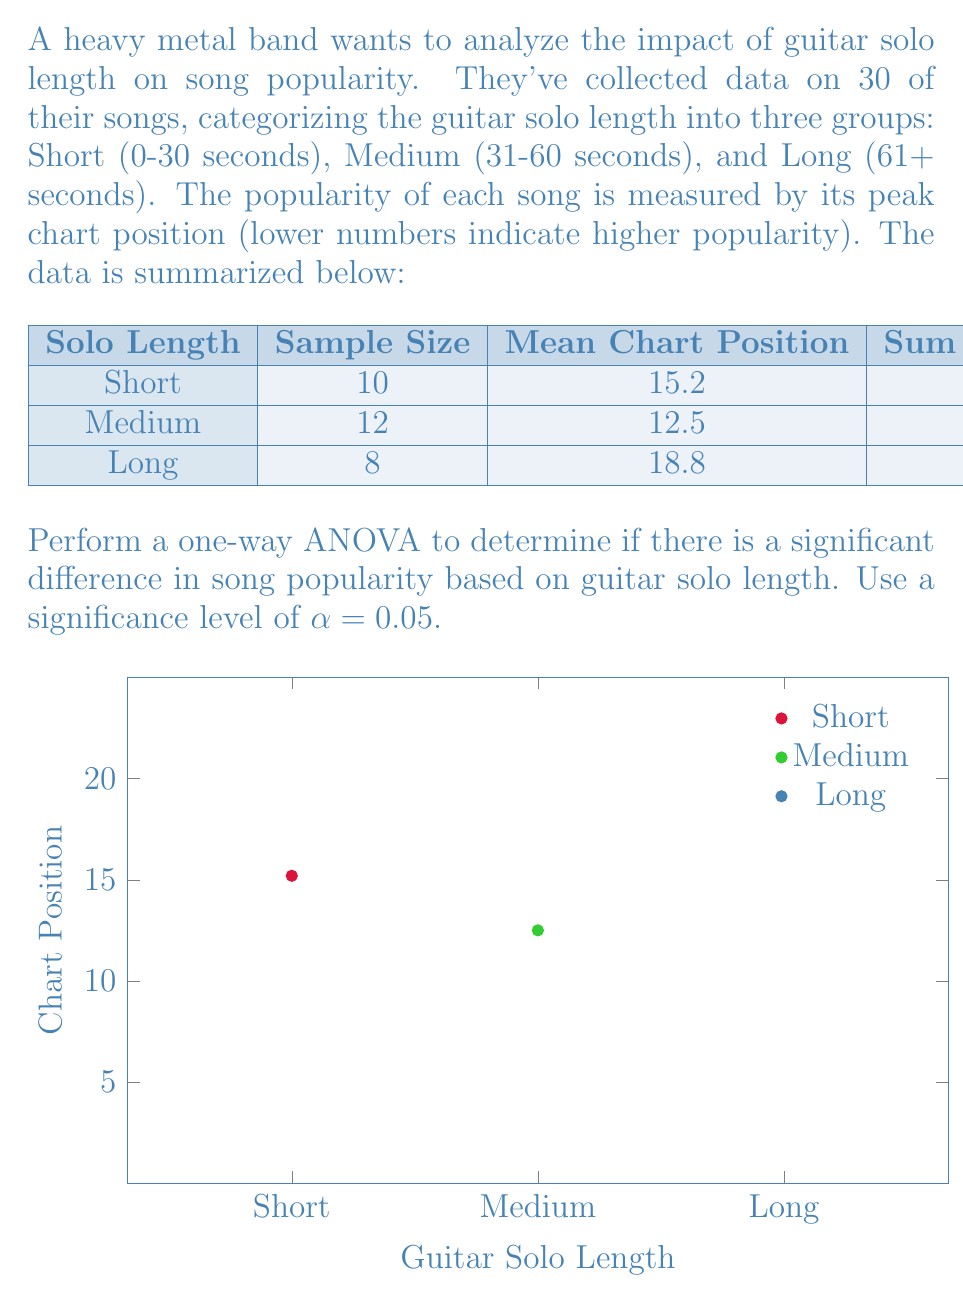Can you solve this math problem? Let's perform the one-way ANOVA step by step:

1) First, calculate the total sum of squares (SST):
   $$SST = 450 + 600 + 320 = 1370$$

2) Calculate the between-group sum of squares (SSB):
   $$\begin{align}
   SSB &= 10(15.2 - \bar{x})^2 + 12(12.5 - \bar{x})^2 + 8(18.8 - \bar{x})^2 \\
   \text{where } \bar{x} &= \frac{10(15.2) + 12(12.5) + 8(18.8)}{30} = 15.1
   \end{align}$$
   
   $$SSB = 10(-0.1)^2 + 12(-2.6)^2 + 8(3.7)^2 = 256.47$$

3) Calculate the within-group sum of squares (SSW):
   $$SSW = SST - SSB = 1370 - 256.47 = 1113.53$$

4) Calculate degrees of freedom:
   $$\begin{align}
   df_{between} &= k - 1 = 3 - 1 = 2 \\
   df_{within} &= N - k = 30 - 3 = 27 \\
   df_{total} &= N - 1 = 30 - 1 = 29
   \end{align}$$

5) Calculate mean squares:
   $$\begin{align}
   MS_{between} &= \frac{SSB}{df_{between}} = \frac{256.47}{2} = 128.235 \\
   MS_{within} &= \frac{SSW}{df_{within}} = \frac{1113.53}{27} = 41.242
   \end{align}$$

6) Calculate the F-statistic:
   $$F = \frac{MS_{between}}{MS_{within}} = \frac{128.235}{41.242} = 3.109$$

7) Find the critical F-value:
   For α = 0.05, df₁ = 2, df₂ = 27, the critical F-value is approximately 3.354.

8) Compare the calculated F-statistic to the critical F-value:
   Since 3.109 < 3.354, we fail to reject the null hypothesis.
Answer: F(2,27) = 3.109, p > 0.05. No significant difference in song popularity based on guitar solo length. 